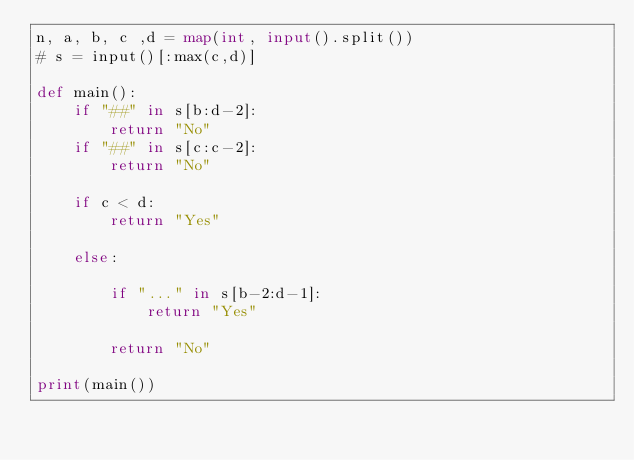Convert code to text. <code><loc_0><loc_0><loc_500><loc_500><_Python_>n, a, b, c ,d = map(int, input().split())
# s = input()[:max(c,d)]

def main():
    if "##" in s[b:d-2]:
        return "No"
    if "##" in s[c:c-2]:
        return "No"

    if c < d:
        return "Yes"
    
    else:

        if "..." in s[b-2:d-1]:
            return "Yes"
                
        return "No"

print(main())</code> 